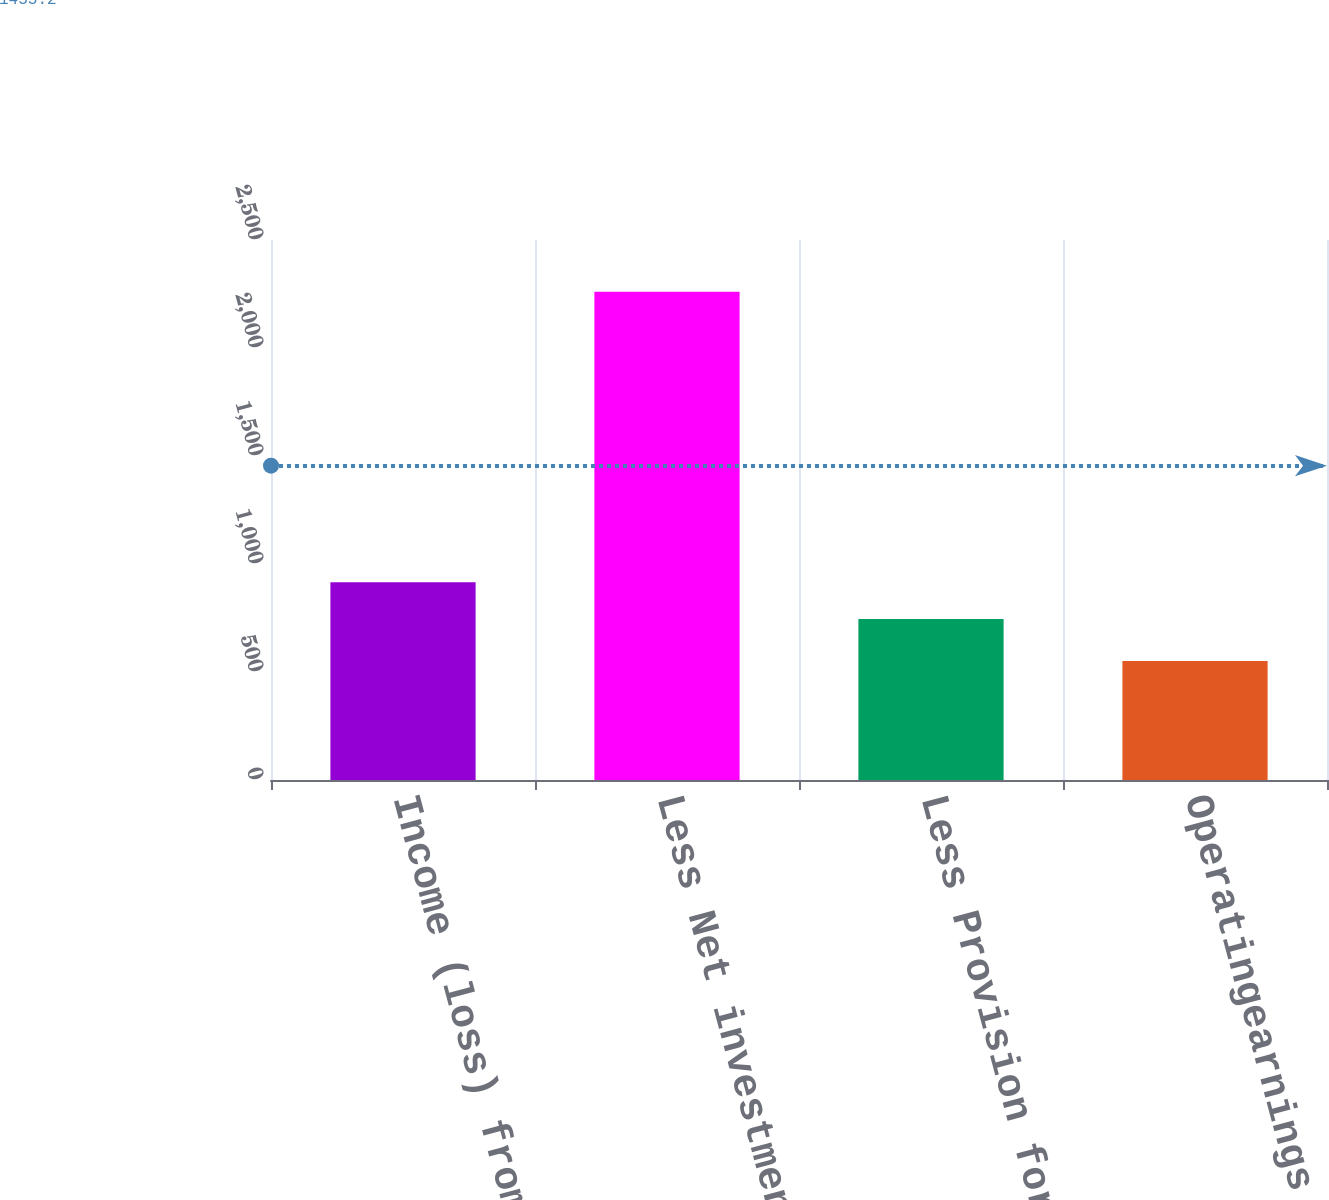Convert chart. <chart><loc_0><loc_0><loc_500><loc_500><bar_chart><fcel>Income (loss) from continuing<fcel>Less Net investment gains<fcel>Less Provision for income tax<fcel>Operatingearnings<nl><fcel>915.9<fcel>2260<fcel>745<fcel>551<nl></chart> 